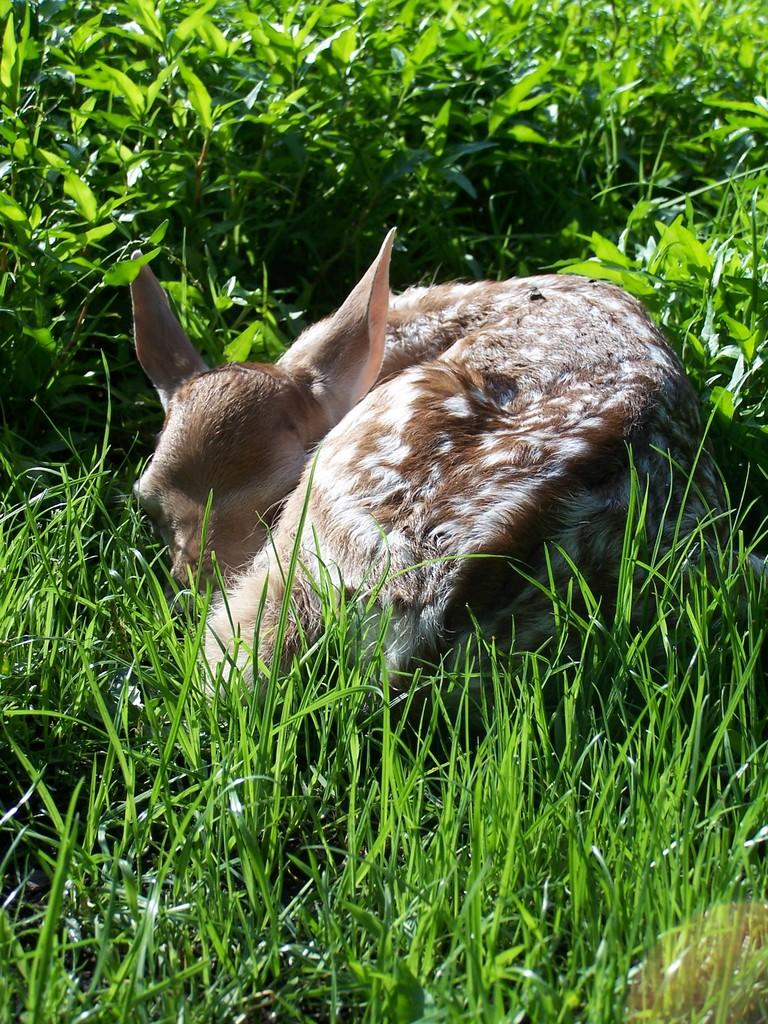What type of creature is in the image? There is an animal in the image. Where is the animal located? The animal is on the grass. What other living organisms can be seen in the image? There are plants in the image. What color is the kite that the animal is holding in the image? There is no kite present in the image. What does the animal desire in the image? The image does not provide information about the animal's desires. 